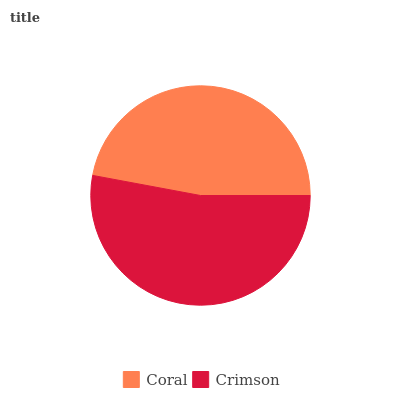Is Coral the minimum?
Answer yes or no. Yes. Is Crimson the maximum?
Answer yes or no. Yes. Is Crimson the minimum?
Answer yes or no. No. Is Crimson greater than Coral?
Answer yes or no. Yes. Is Coral less than Crimson?
Answer yes or no. Yes. Is Coral greater than Crimson?
Answer yes or no. No. Is Crimson less than Coral?
Answer yes or no. No. Is Crimson the high median?
Answer yes or no. Yes. Is Coral the low median?
Answer yes or no. Yes. Is Coral the high median?
Answer yes or no. No. Is Crimson the low median?
Answer yes or no. No. 